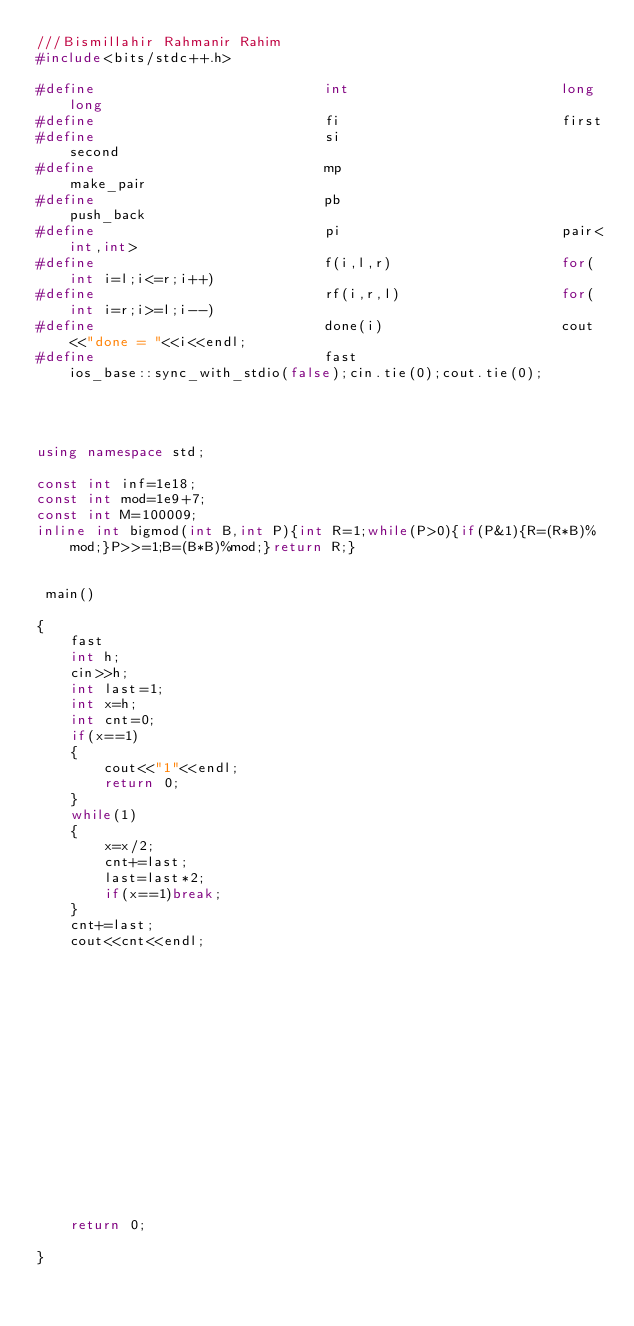<code> <loc_0><loc_0><loc_500><loc_500><_C++_>///Bismillahir Rahmanir Rahim
#include<bits/stdc++.h>

#define                           int                         long long
#define                           fi                          first
#define                           si                          second
#define                           mp                          make_pair
#define                           pb                          push_back
#define                           pi                          pair<int,int>
#define                           f(i,l,r)                    for(int i=l;i<=r;i++)
#define                           rf(i,r,l)                   for(int i=r;i>=l;i--)
#define                           done(i)                     cout<<"done = "<<i<<endl;
#define                           fast                        ios_base::sync_with_stdio(false);cin.tie(0);cout.tie(0);




using namespace std;

const int inf=1e18;
const int mod=1e9+7;
const int M=100009;
inline int bigmod(int B,int P){int R=1;while(P>0){if(P&1){R=(R*B)%mod;}P>>=1;B=(B*B)%mod;}return R;}


 main()

{
    fast
    int h;
    cin>>h;
    int last=1;
    int x=h;
    int cnt=0;
    if(x==1)
    {
        cout<<"1"<<endl;
        return 0;
    }
    while(1)
    {
        x=x/2;
        cnt+=last;
        last=last*2;
        if(x==1)break;
    }
    cnt+=last;
    cout<<cnt<<endl;

















    return 0;

}











</code> 